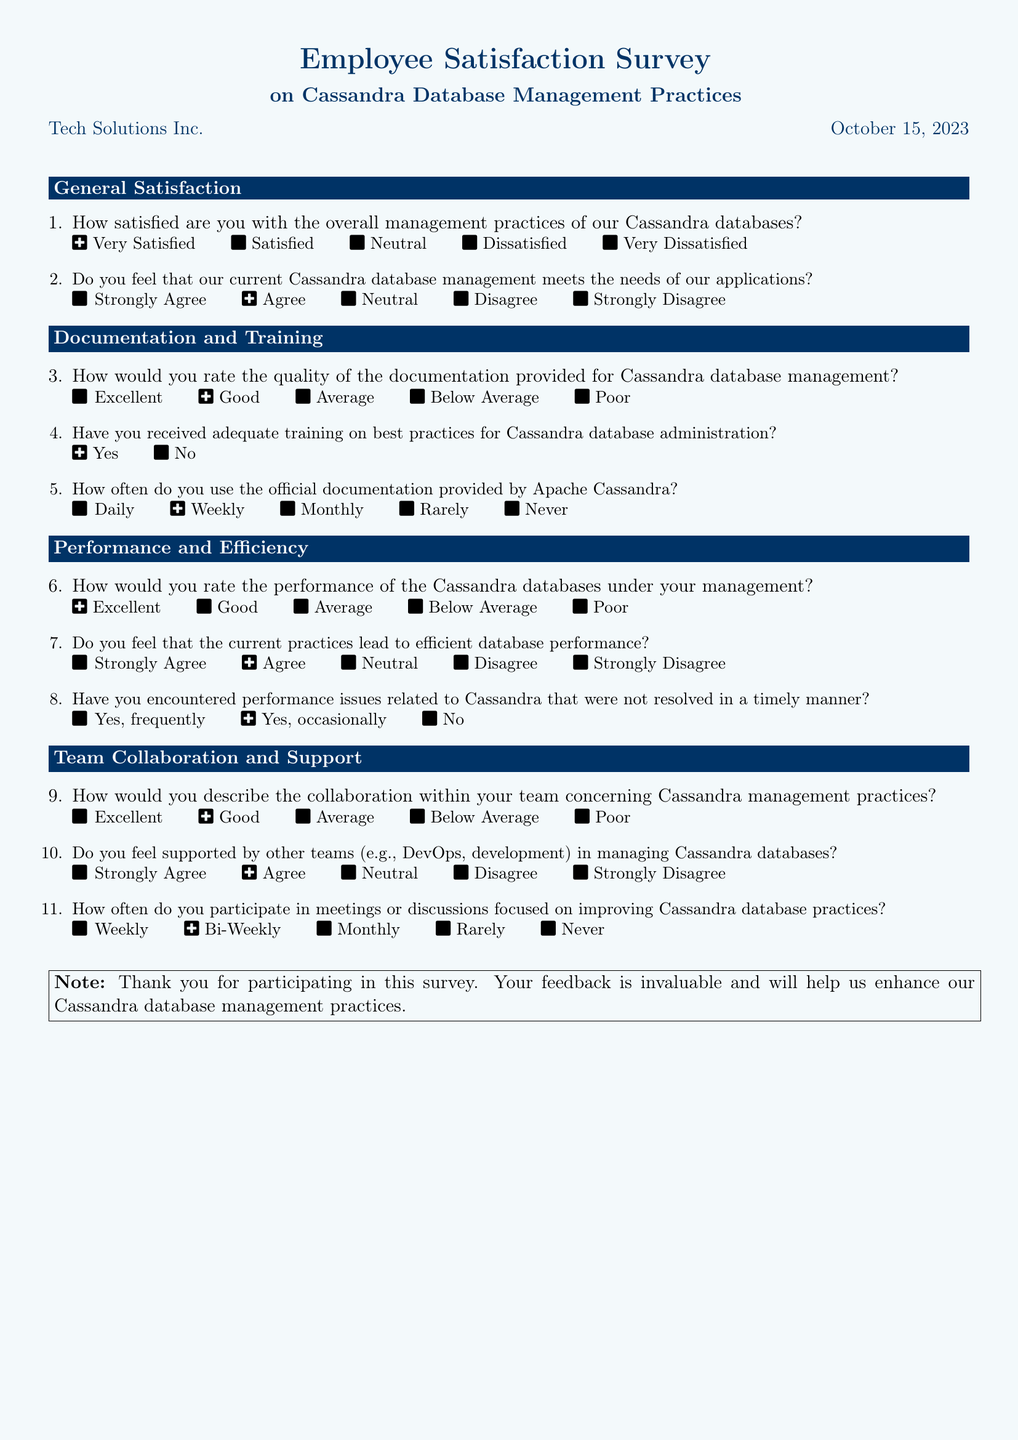What is the title of the survey? The title of the survey is prominently displayed at the top of the document.
Answer: Employee Satisfaction Survey Who conducted the survey? The organization responsible for the survey is mentioned in the document.
Answer: Tech Solutions Inc What is the date of the survey? The date is indicated near the title of the survey.
Answer: October 15, 2023 How many sections does the survey have? The number of sections is determined by the headings in the document.
Answer: Four What is the first question in the "General Satisfaction" section? The first question is listed under the "General Satisfaction" heading.
Answer: How satisfied are you with the overall management practices of our Cassandra databases? How often do employees use the official documentation provided by Apache Cassandra? This question is included in the "Documentation and Training" section of the survey.
Answer: Daily How would you rate the performance of the Cassandra databases under your management? This question is found in the "Performance and Efficiency" section.
Answer: Excellent How often do employees participate in meetings focused on improving database practices? This question is included in the "Team Collaboration and Support" section.
Answer: Weekly Do most employees feel that current practices lead to efficient database performance? This is evaluated in the "Performance and Efficiency" section of the survey.
Answer: Neutral 